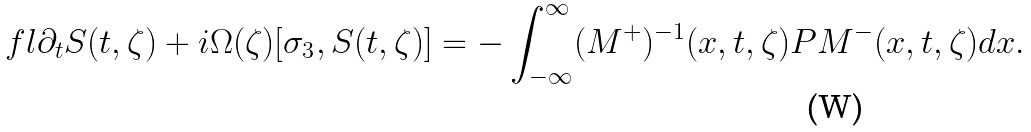Convert formula to latex. <formula><loc_0><loc_0><loc_500><loc_500>\ f l \partial _ { t } S ( t , \zeta ) + i \Omega ( \zeta ) [ \sigma _ { 3 } , S ( t , \zeta ) ] = - \int _ { - \infty } ^ { \infty } ( M ^ { + } ) ^ { - 1 } ( x , t , \zeta ) P M ^ { - } ( x , t , \zeta ) d x .</formula> 